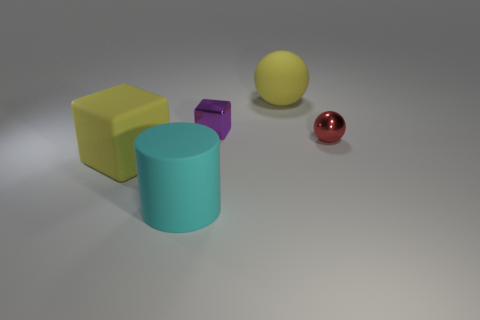Add 1 large cylinders. How many objects exist? 6 Subtract all red balls. How many balls are left? 1 Add 5 big cubes. How many big cubes exist? 6 Subtract 0 green cylinders. How many objects are left? 5 Subtract all balls. How many objects are left? 3 Subtract 2 blocks. How many blocks are left? 0 Subtract all brown balls. Subtract all red cubes. How many balls are left? 2 Subtract all yellow balls. How many purple cylinders are left? 0 Subtract all brown metal things. Subtract all yellow objects. How many objects are left? 3 Add 1 tiny objects. How many tiny objects are left? 3 